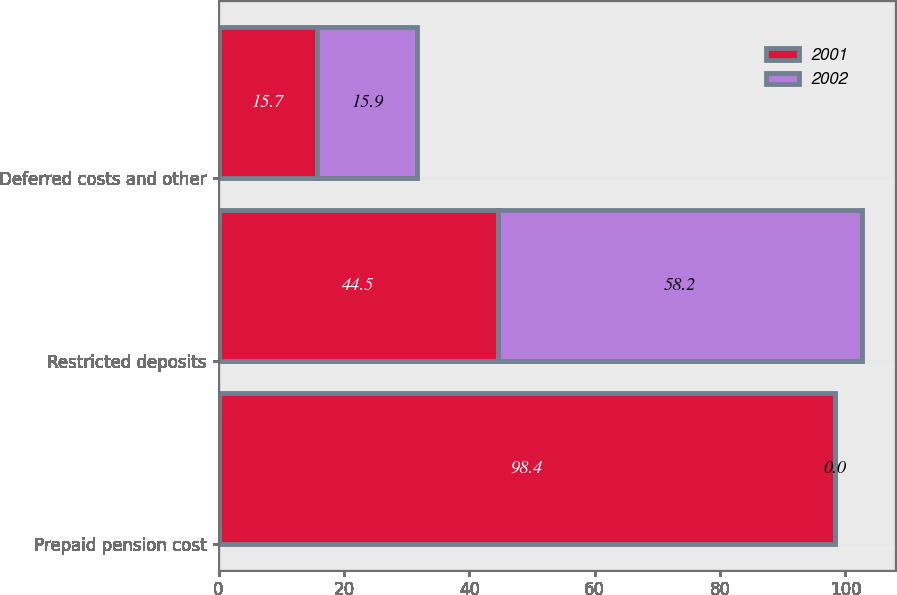Convert chart. <chart><loc_0><loc_0><loc_500><loc_500><stacked_bar_chart><ecel><fcel>Prepaid pension cost<fcel>Restricted deposits<fcel>Deferred costs and other<nl><fcel>2001<fcel>98.4<fcel>44.5<fcel>15.7<nl><fcel>2002<fcel>0<fcel>58.2<fcel>15.9<nl></chart> 